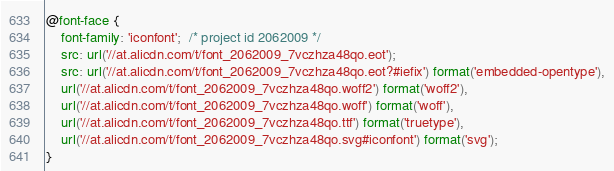Convert code to text. <code><loc_0><loc_0><loc_500><loc_500><_CSS_>@font-face {
    font-family: 'iconfont';  /* project id 2062009 */
    src: url('//at.alicdn.com/t/font_2062009_7vczhza48qo.eot');
    src: url('//at.alicdn.com/t/font_2062009_7vczhza48qo.eot?#iefix') format('embedded-opentype'),
    url('//at.alicdn.com/t/font_2062009_7vczhza48qo.woff2') format('woff2'),
    url('//at.alicdn.com/t/font_2062009_7vczhza48qo.woff') format('woff'),
    url('//at.alicdn.com/t/font_2062009_7vczhza48qo.ttf') format('truetype'),
    url('//at.alicdn.com/t/font_2062009_7vczhza48qo.svg#iconfont') format('svg');
}
</code> 